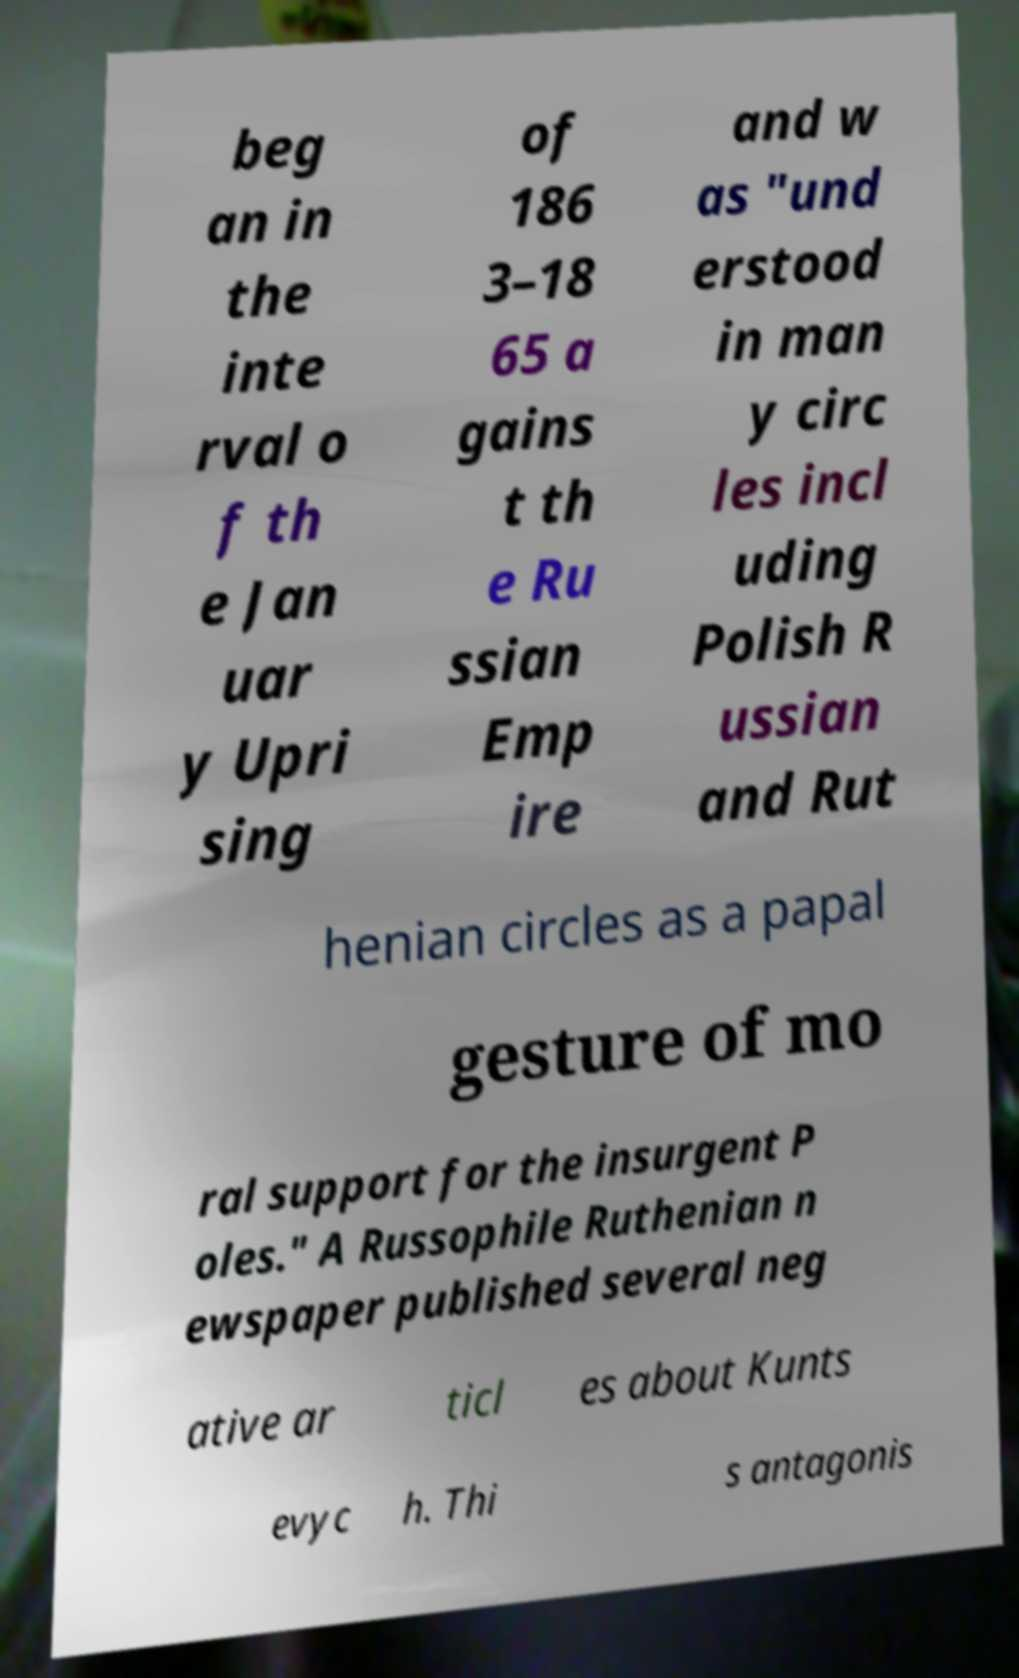I need the written content from this picture converted into text. Can you do that? beg an in the inte rval o f th e Jan uar y Upri sing of 186 3–18 65 a gains t th e Ru ssian Emp ire and w as "und erstood in man y circ les incl uding Polish R ussian and Rut henian circles as a papal gesture of mo ral support for the insurgent P oles." A Russophile Ruthenian n ewspaper published several neg ative ar ticl es about Kunts evyc h. Thi s antagonis 